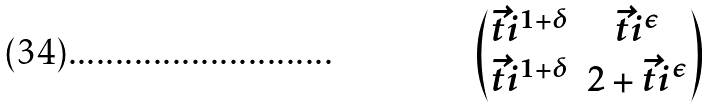Convert formula to latex. <formula><loc_0><loc_0><loc_500><loc_500>\begin{pmatrix} \vec { t } i ^ { 1 + \delta } & \vec { t } i ^ { \epsilon } \\ \vec { t } i ^ { 1 + \delta } & 2 + \vec { t } i ^ { \epsilon } \end{pmatrix}</formula> 